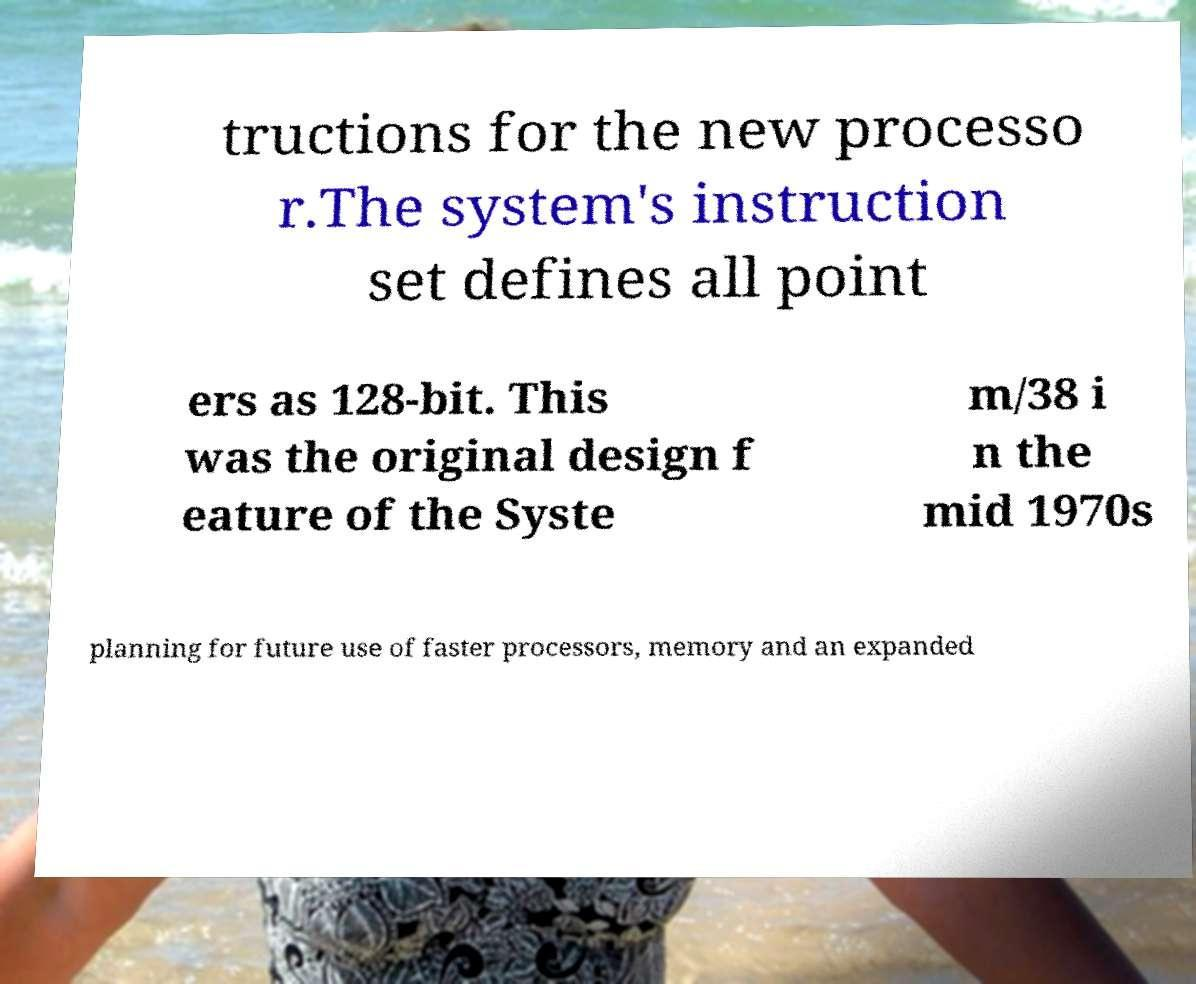I need the written content from this picture converted into text. Can you do that? tructions for the new processo r.The system's instruction set defines all point ers as 128-bit. This was the original design f eature of the Syste m/38 i n the mid 1970s planning for future use of faster processors, memory and an expanded 